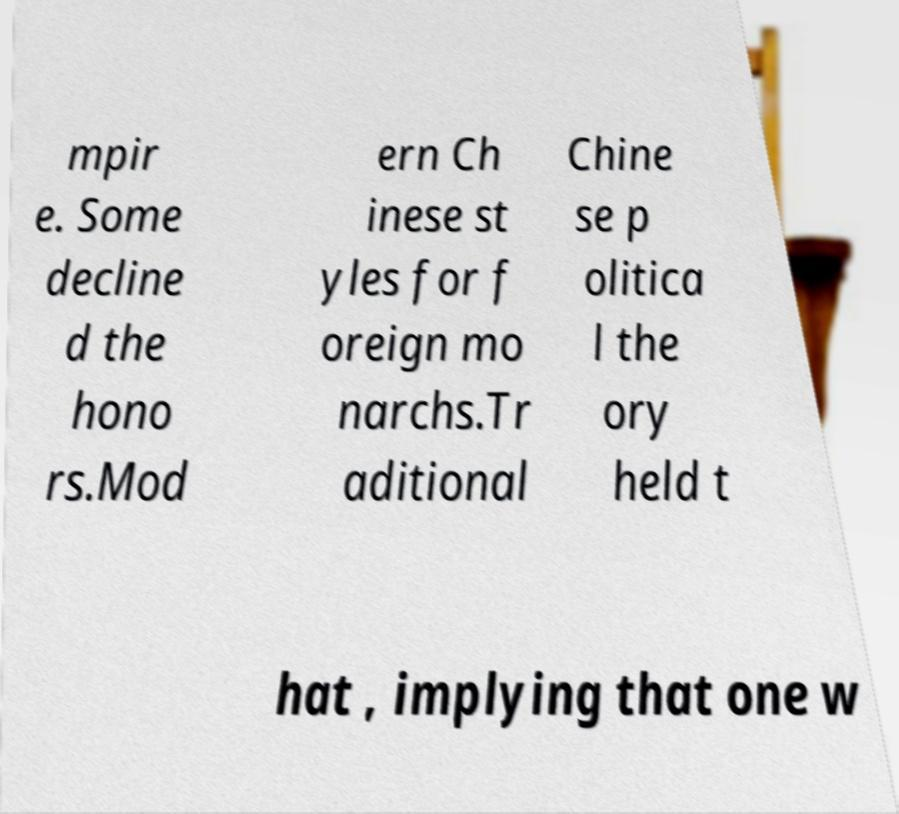What messages or text are displayed in this image? I need them in a readable, typed format. mpir e. Some decline d the hono rs.Mod ern Ch inese st yles for f oreign mo narchs.Tr aditional Chine se p olitica l the ory held t hat , implying that one w 